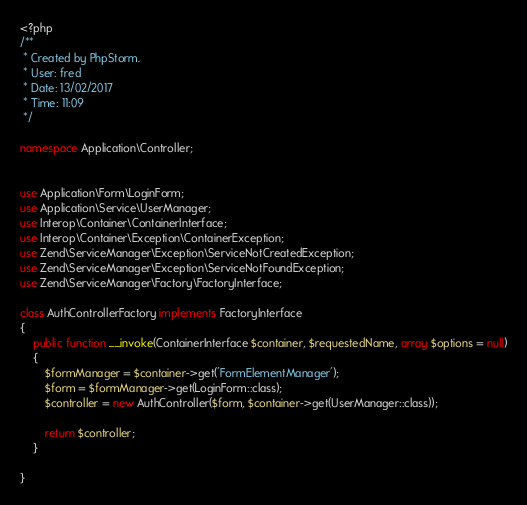Convert code to text. <code><loc_0><loc_0><loc_500><loc_500><_PHP_><?php
/**
 * Created by PhpStorm.
 * User: fred
 * Date: 13/02/2017
 * Time: 11:09
 */

namespace Application\Controller;


use Application\Form\LoginForm;
use Application\Service\UserManager;
use Interop\Container\ContainerInterface;
use Interop\Container\Exception\ContainerException;
use Zend\ServiceManager\Exception\ServiceNotCreatedException;
use Zend\ServiceManager\Exception\ServiceNotFoundException;
use Zend\ServiceManager\Factory\FactoryInterface;

class AuthControllerFactory implements FactoryInterface
{
    public function __invoke(ContainerInterface $container, $requestedName, array $options = null)
    {
        $formManager = $container->get('FormElementManager');
        $form = $formManager->get(LoginForm::class);
        $controller = new AuthController($form, $container->get(UserManager::class));
        
        return $controller;
    }

}</code> 